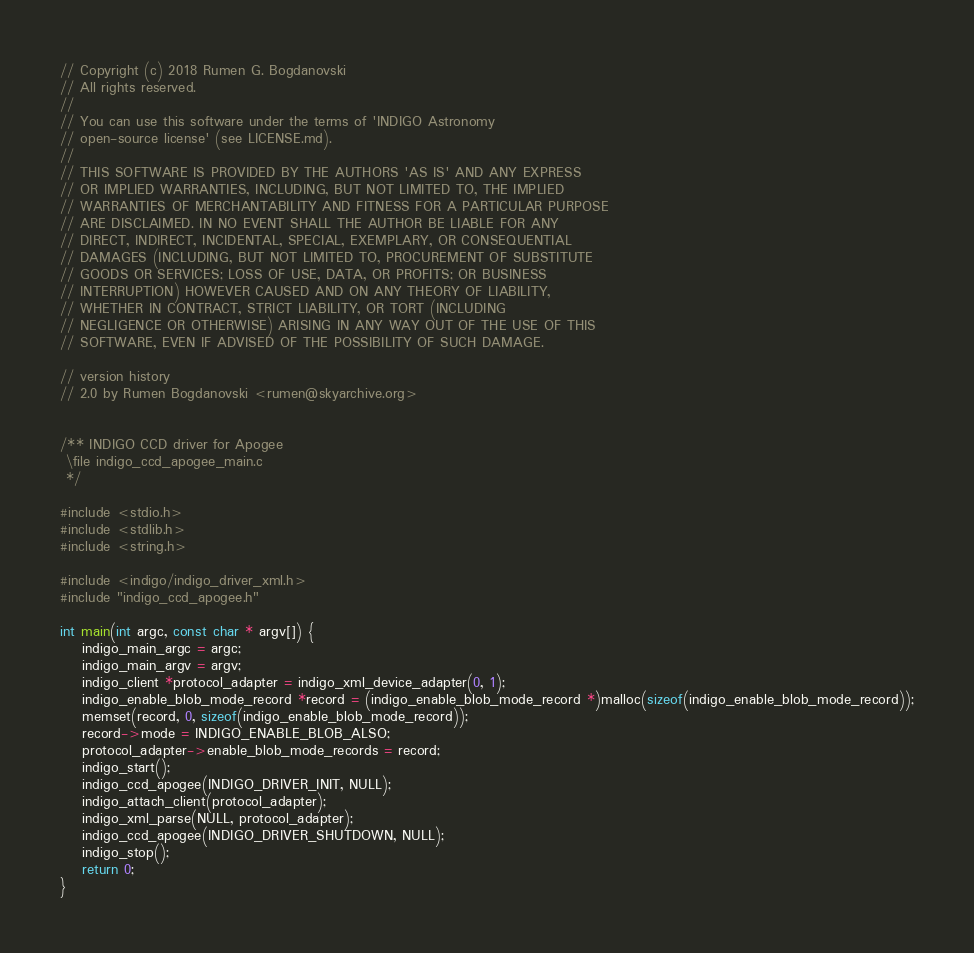<code> <loc_0><loc_0><loc_500><loc_500><_C++_>// Copyright (c) 2018 Rumen G. Bogdanovski
// All rights reserved.
//
// You can use this software under the terms of 'INDIGO Astronomy
// open-source license' (see LICENSE.md).
//
// THIS SOFTWARE IS PROVIDED BY THE AUTHORS 'AS IS' AND ANY EXPRESS
// OR IMPLIED WARRANTIES, INCLUDING, BUT NOT LIMITED TO, THE IMPLIED
// WARRANTIES OF MERCHANTABILITY AND FITNESS FOR A PARTICULAR PURPOSE
// ARE DISCLAIMED. IN NO EVENT SHALL THE AUTHOR BE LIABLE FOR ANY
// DIRECT, INDIRECT, INCIDENTAL, SPECIAL, EXEMPLARY, OR CONSEQUENTIAL
// DAMAGES (INCLUDING, BUT NOT LIMITED TO, PROCUREMENT OF SUBSTITUTE
// GOODS OR SERVICES; LOSS OF USE, DATA, OR PROFITS; OR BUSINESS
// INTERRUPTION) HOWEVER CAUSED AND ON ANY THEORY OF LIABILITY,
// WHETHER IN CONTRACT, STRICT LIABILITY, OR TORT (INCLUDING
// NEGLIGENCE OR OTHERWISE) ARISING IN ANY WAY OUT OF THE USE OF THIS
// SOFTWARE, EVEN IF ADVISED OF THE POSSIBILITY OF SUCH DAMAGE.

// version history
// 2.0 by Rumen Bogdanovski <rumen@skyarchive.org>


/** INDIGO CCD driver for Apogee
 \file indigo_ccd_apogee_main.c
 */

#include <stdio.h>
#include <stdlib.h>
#include <string.h>

#include <indigo/indigo_driver_xml.h>
#include "indigo_ccd_apogee.h"

int main(int argc, const char * argv[]) {
	indigo_main_argc = argc;
	indigo_main_argv = argv;
	indigo_client *protocol_adapter = indigo_xml_device_adapter(0, 1);
	indigo_enable_blob_mode_record *record = (indigo_enable_blob_mode_record *)malloc(sizeof(indigo_enable_blob_mode_record));
	memset(record, 0, sizeof(indigo_enable_blob_mode_record));
	record->mode = INDIGO_ENABLE_BLOB_ALSO;
	protocol_adapter->enable_blob_mode_records = record;
	indigo_start();
	indigo_ccd_apogee(INDIGO_DRIVER_INIT, NULL);
	indigo_attach_client(protocol_adapter);
	indigo_xml_parse(NULL, protocol_adapter);
	indigo_ccd_apogee(INDIGO_DRIVER_SHUTDOWN, NULL);
	indigo_stop();
	return 0;
}
</code> 